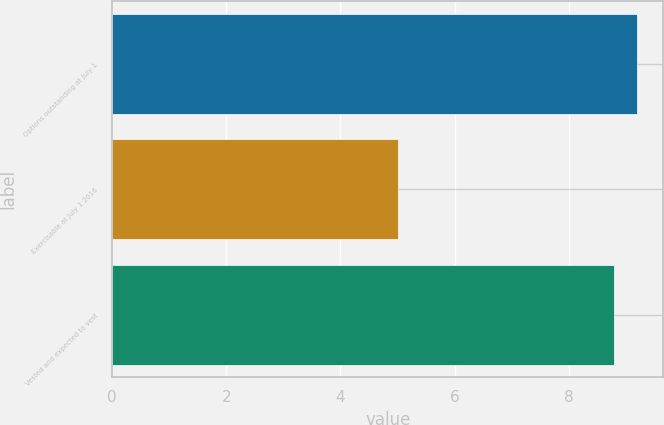Convert chart. <chart><loc_0><loc_0><loc_500><loc_500><bar_chart><fcel>Options outstanding at July 1<fcel>Exercisable at July 1 2016<fcel>Vested and expected to vest<nl><fcel>9.2<fcel>5<fcel>8.8<nl></chart> 